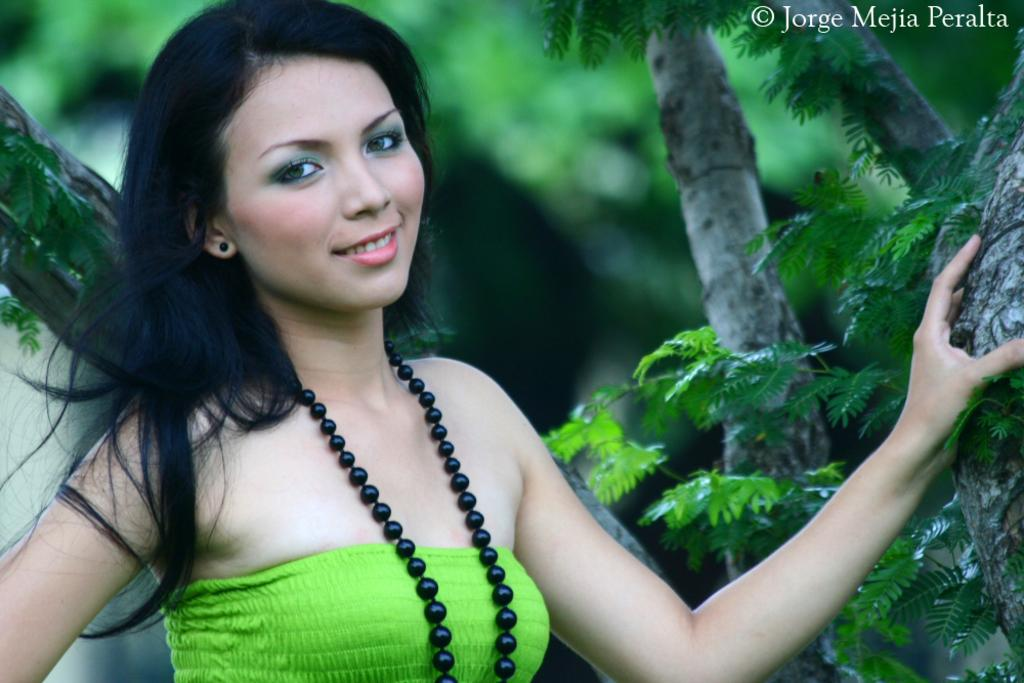Who is present in the image? There is a woman in the image. What is the woman's facial expression? The woman is smiling. What can be seen in the background of the image? There are trees in the background of the image. What type of beast can be seen accompanying the woman in the image? There is no beast present in the image; it only features a woman and trees in the background. 